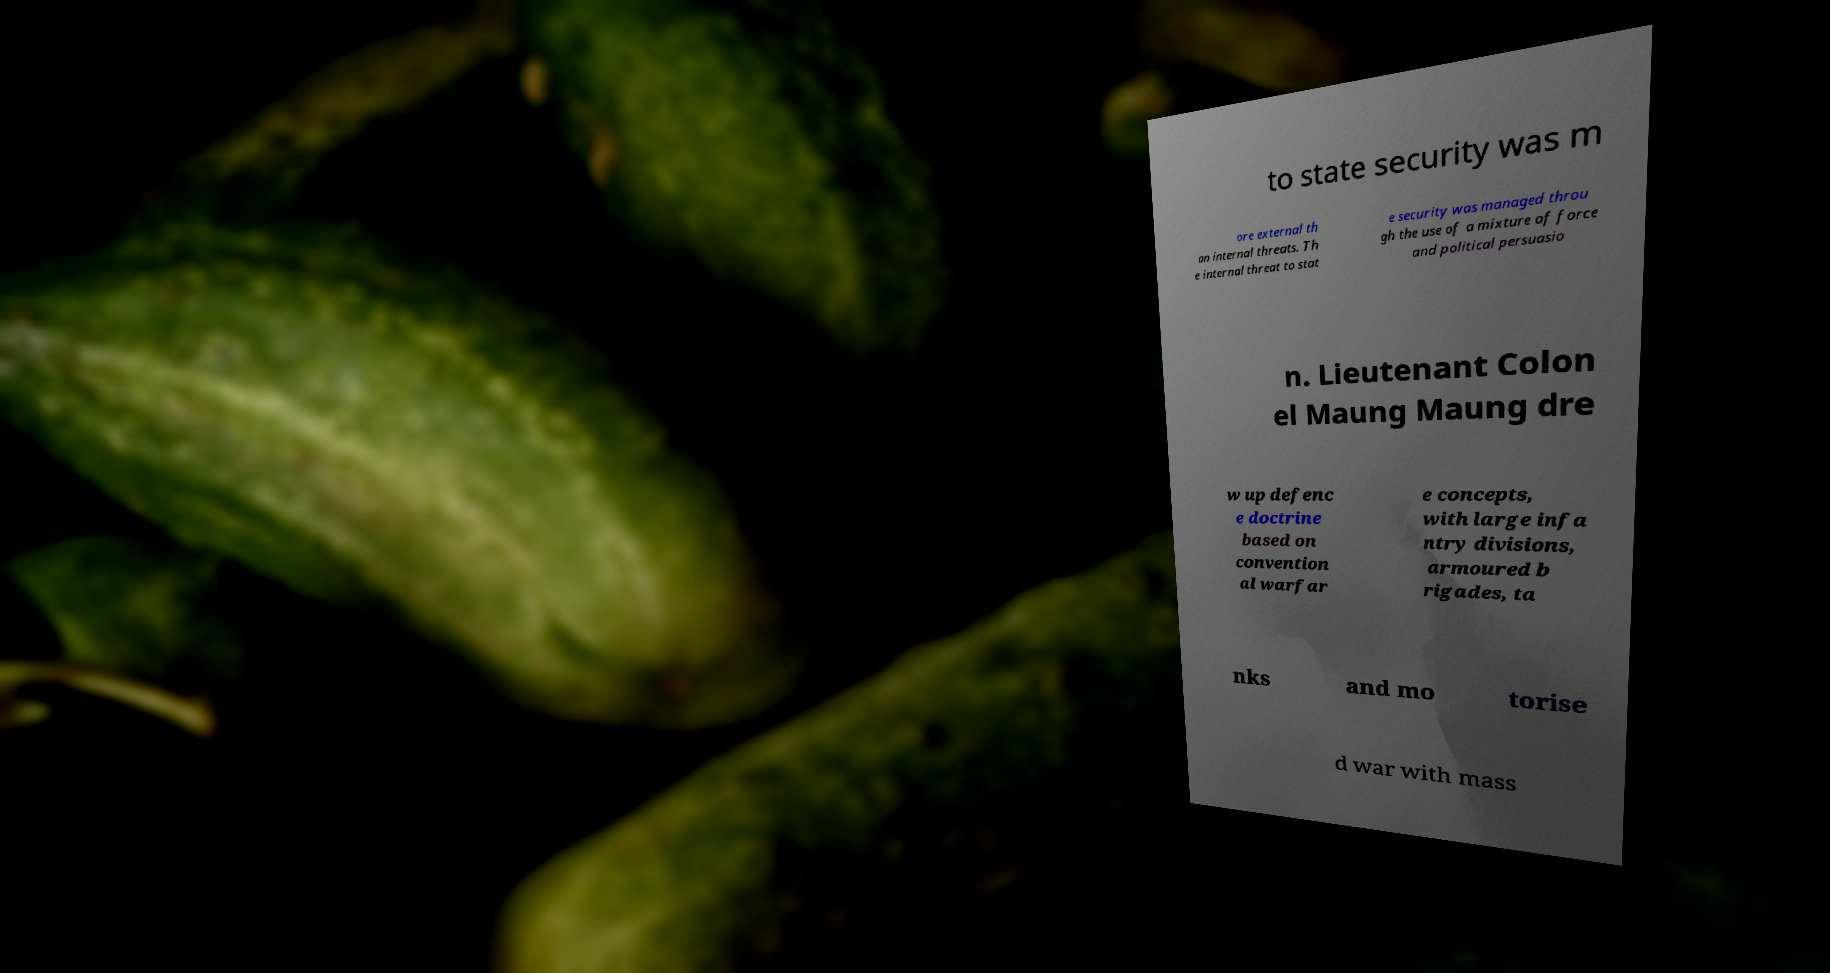Can you read and provide the text displayed in the image?This photo seems to have some interesting text. Can you extract and type it out for me? to state security was m ore external th an internal threats. Th e internal threat to stat e security was managed throu gh the use of a mixture of force and political persuasio n. Lieutenant Colon el Maung Maung dre w up defenc e doctrine based on convention al warfar e concepts, with large infa ntry divisions, armoured b rigades, ta nks and mo torise d war with mass 